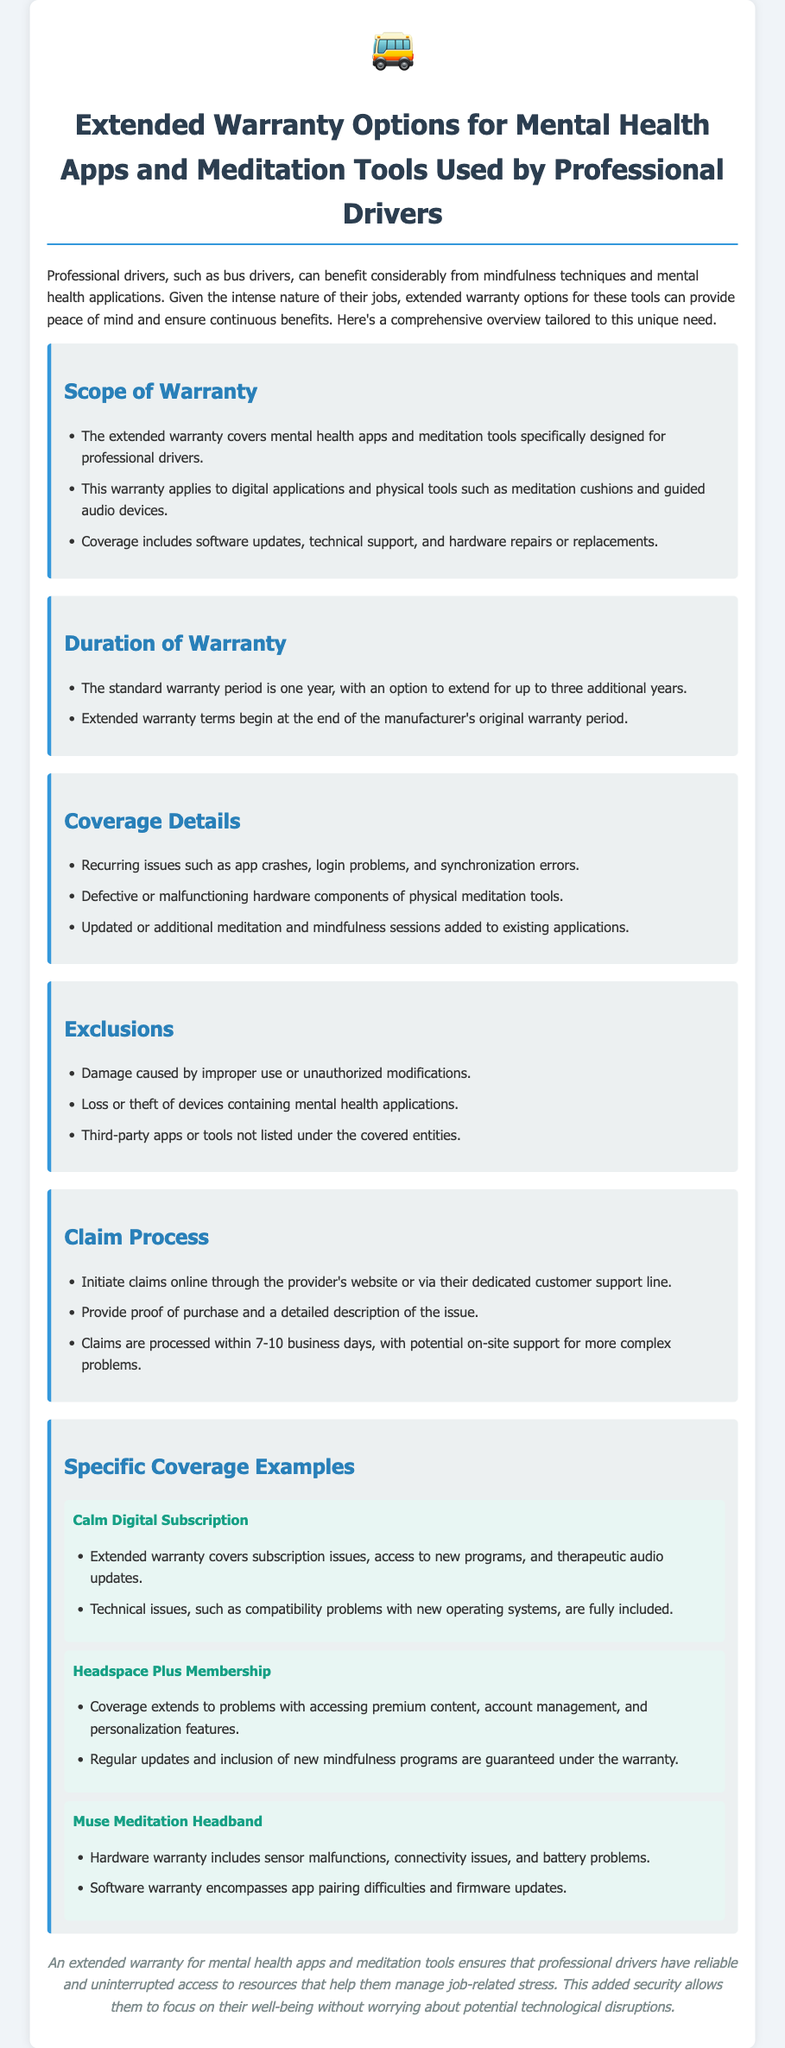what does the extended warranty cover? The warranty covers mental health apps and meditation tools specifically designed for professional drivers, including software updates, technical support, and hardware repairs or replacements.
Answer: mental health apps and meditation tools what is the standard warranty period? The standard warranty period is mentioned in the document, which states the duration for the warranty.
Answer: one year how long can the warranty be extended for? The document specifies how long the warranty can be extended beyond the standard period.
Answer: up to three additional years what types of issues are covered under the warranty? The document lists specific types of issues that are included in the warranty coverage.
Answer: app crashes, login problems, and synchronization errors what is excluded from the warranty coverage? The document specifies certain conditions or situations that are not covered under the warranty.
Answer: damage caused by improper use how is the claim process initiated? The document describes the initial step to begin a claim process for warranty issues.
Answer: online through the provider's website how long does it take to process claims? The timeframe for processing claims is outlined in the document.
Answer: 7-10 business days name one example of a covered item. The document lists specific items that are included under the warranty, to illustrate the type of coverage available.
Answer: Calm Digital Subscription what should be provided when making a claim? The document indicates what information is necessary to start the claims process.
Answer: proof of purchase and a detailed description of the issue 